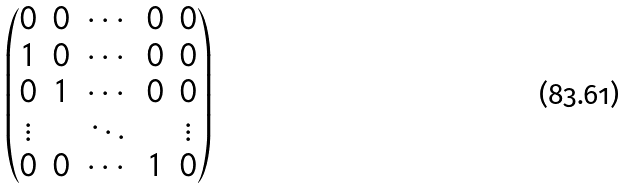<formula> <loc_0><loc_0><loc_500><loc_500>\begin{pmatrix} 0 & 0 & \cdots & 0 & 0 \\ 1 & 0 & \cdots & 0 & 0 \\ 0 & 1 & \cdots & 0 & 0 \\ \vdots & & \ddots & & \vdots \\ 0 & 0 & \cdots & 1 & 0 \end{pmatrix}</formula> 